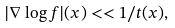<formula> <loc_0><loc_0><loc_500><loc_500>| \nabla \log f | ( x ) < < 1 / t ( x ) ,</formula> 